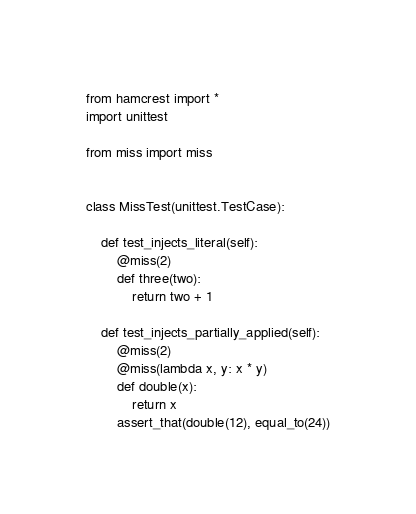<code> <loc_0><loc_0><loc_500><loc_500><_Python_>from hamcrest import *
import unittest

from miss import miss


class MissTest(unittest.TestCase):

    def test_injects_literal(self):
        @miss(2)
        def three(two):
            return two + 1

    def test_injects_partially_applied(self):
        @miss(2)
        @miss(lambda x, y: x * y)
        def double(x):
            return x
        assert_that(double(12), equal_to(24))
</code> 